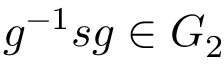Convert formula to latex. <formula><loc_0><loc_0><loc_500><loc_500>g ^ { - 1 } s g \in G _ { 2 }</formula> 